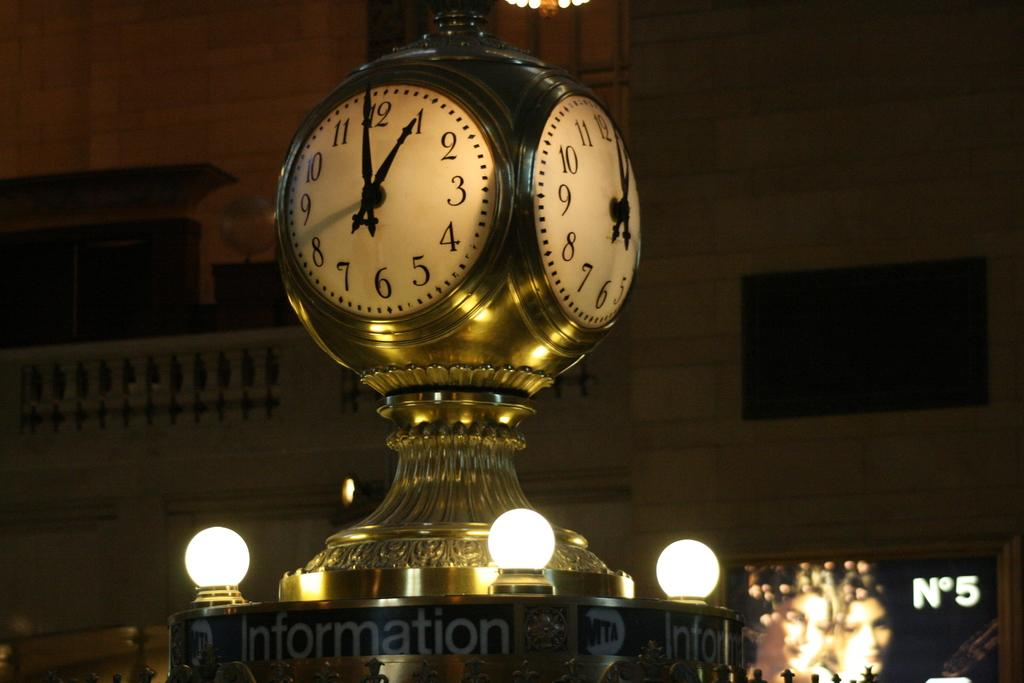<image>
Provide a brief description of the given image. Golden clock on top of a sign which says Information on it. 